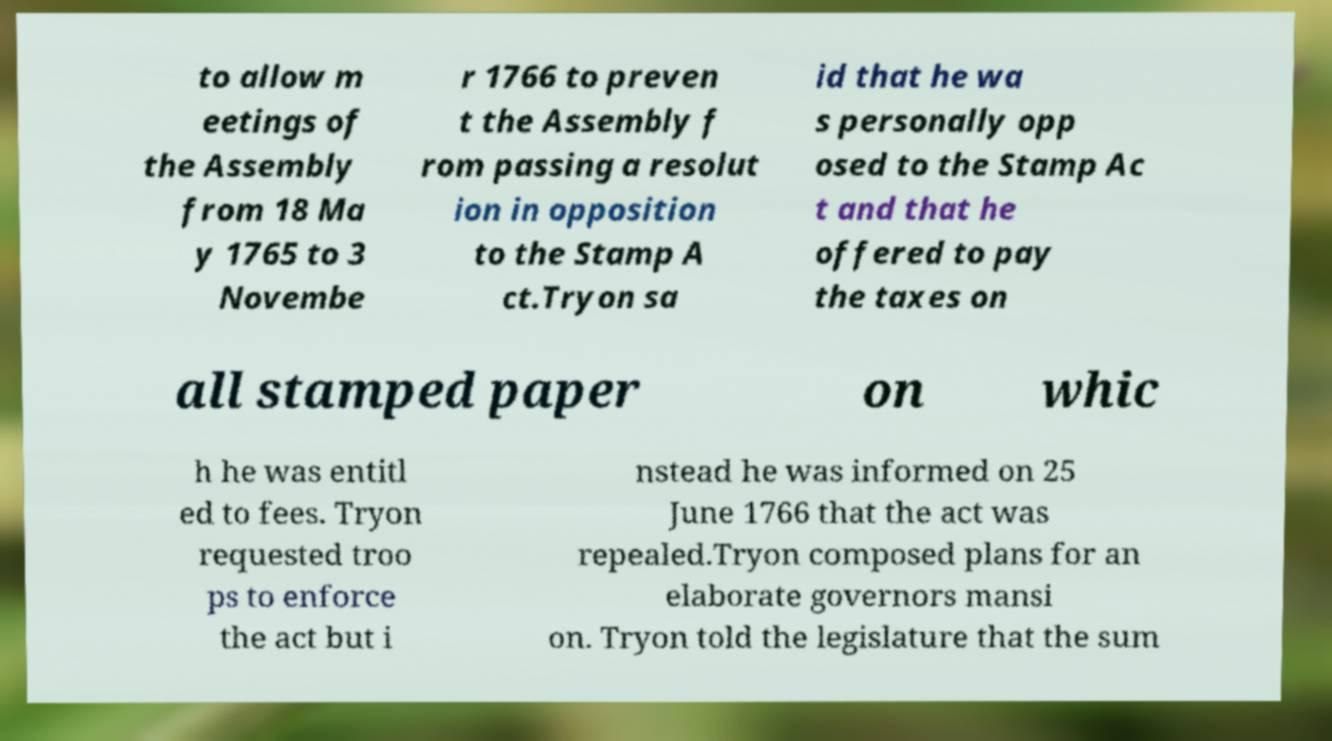Please read and relay the text visible in this image. What does it say? to allow m eetings of the Assembly from 18 Ma y 1765 to 3 Novembe r 1766 to preven t the Assembly f rom passing a resolut ion in opposition to the Stamp A ct.Tryon sa id that he wa s personally opp osed to the Stamp Ac t and that he offered to pay the taxes on all stamped paper on whic h he was entitl ed to fees. Tryon requested troo ps to enforce the act but i nstead he was informed on 25 June 1766 that the act was repealed.Tryon composed plans for an elaborate governors mansi on. Tryon told the legislature that the sum 